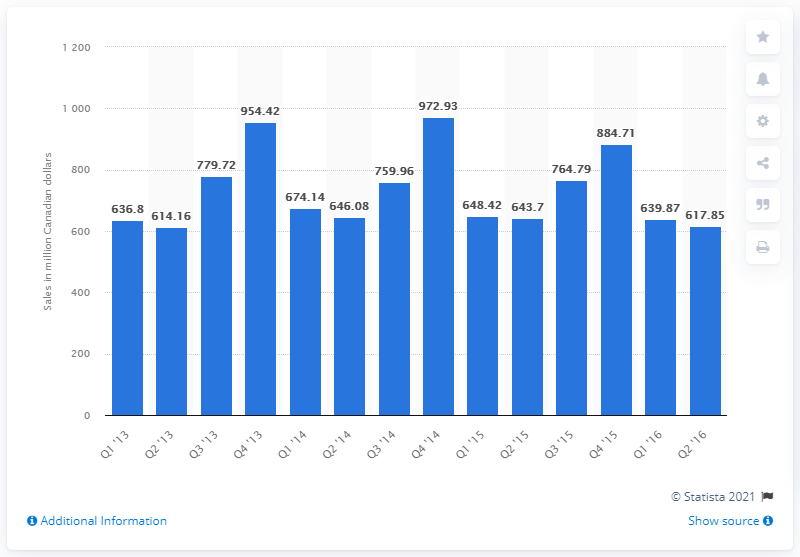Specify some key components in this picture. The sales of stationery, office and party supplies in Canada in the first quarter of 2013 were 639.87. 